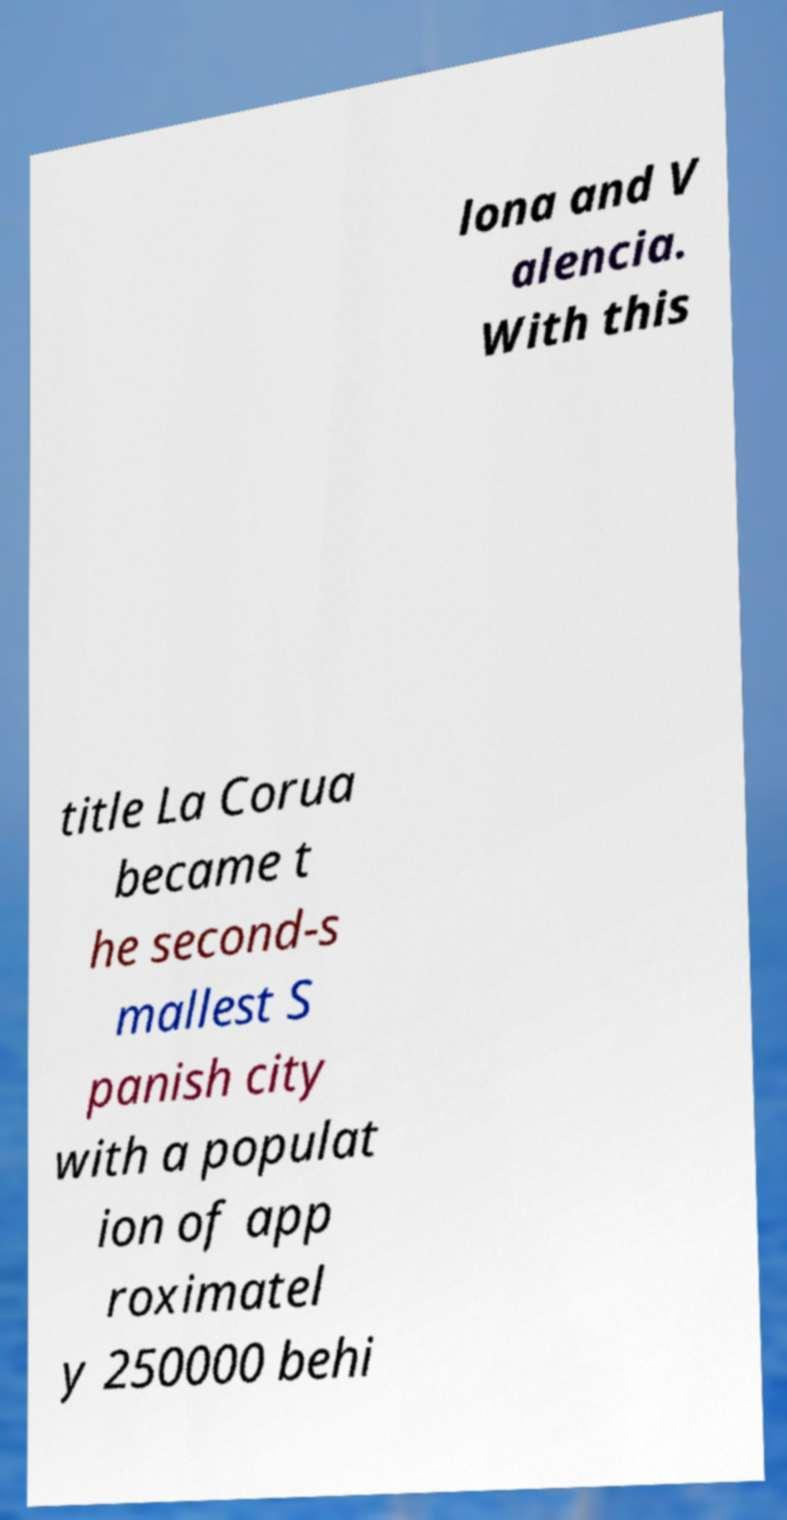Please identify and transcribe the text found in this image. lona and V alencia. With this title La Corua became t he second-s mallest S panish city with a populat ion of app roximatel y 250000 behi 